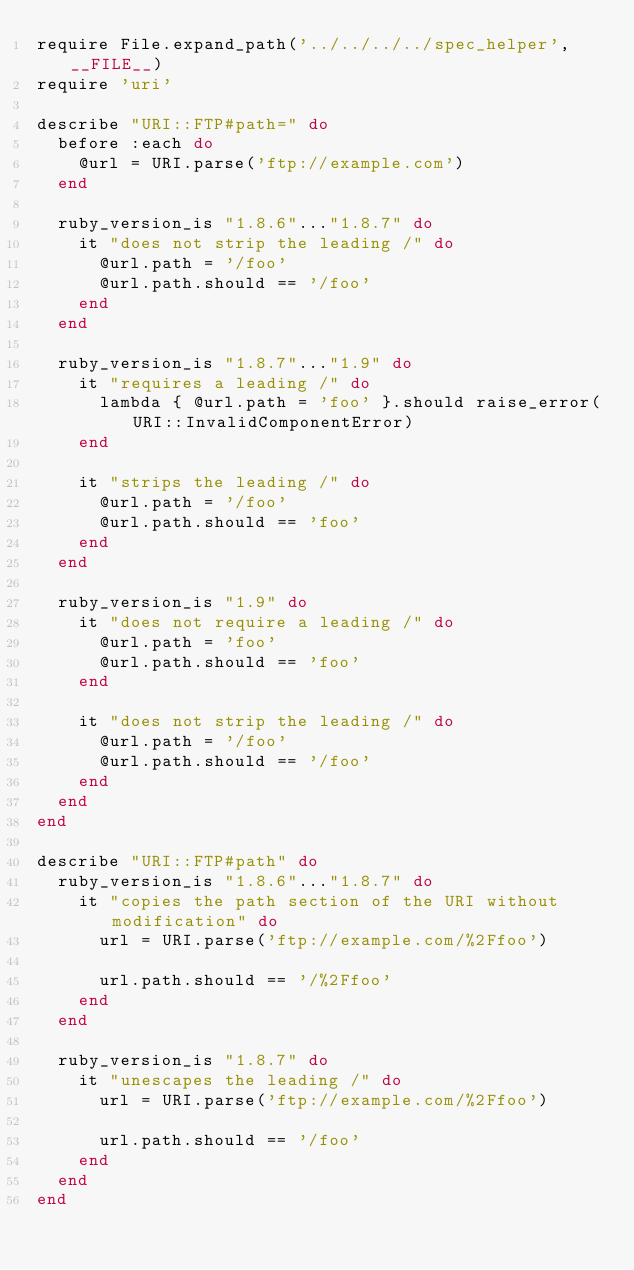<code> <loc_0><loc_0><loc_500><loc_500><_Ruby_>require File.expand_path('../../../../spec_helper', __FILE__)
require 'uri'

describe "URI::FTP#path=" do
  before :each do
    @url = URI.parse('ftp://example.com')
  end

  ruby_version_is "1.8.6"..."1.8.7" do
    it "does not strip the leading /" do
      @url.path = '/foo'
      @url.path.should == '/foo'
    end
  end

  ruby_version_is "1.8.7"..."1.9" do
    it "requires a leading /" do
      lambda { @url.path = 'foo' }.should raise_error(URI::InvalidComponentError)
    end

    it "strips the leading /" do
      @url.path = '/foo'
      @url.path.should == 'foo'
    end
  end

  ruby_version_is "1.9" do
    it "does not require a leading /" do
      @url.path = 'foo'
      @url.path.should == 'foo'
    end

    it "does not strip the leading /" do
      @url.path = '/foo'
      @url.path.should == '/foo'
    end
  end
end

describe "URI::FTP#path" do
  ruby_version_is "1.8.6"..."1.8.7" do
    it "copies the path section of the URI without modification" do
      url = URI.parse('ftp://example.com/%2Ffoo')

      url.path.should == '/%2Ffoo'
    end
  end

  ruby_version_is "1.8.7" do
    it "unescapes the leading /" do
      url = URI.parse('ftp://example.com/%2Ffoo')

      url.path.should == '/foo'
    end
  end
end
</code> 